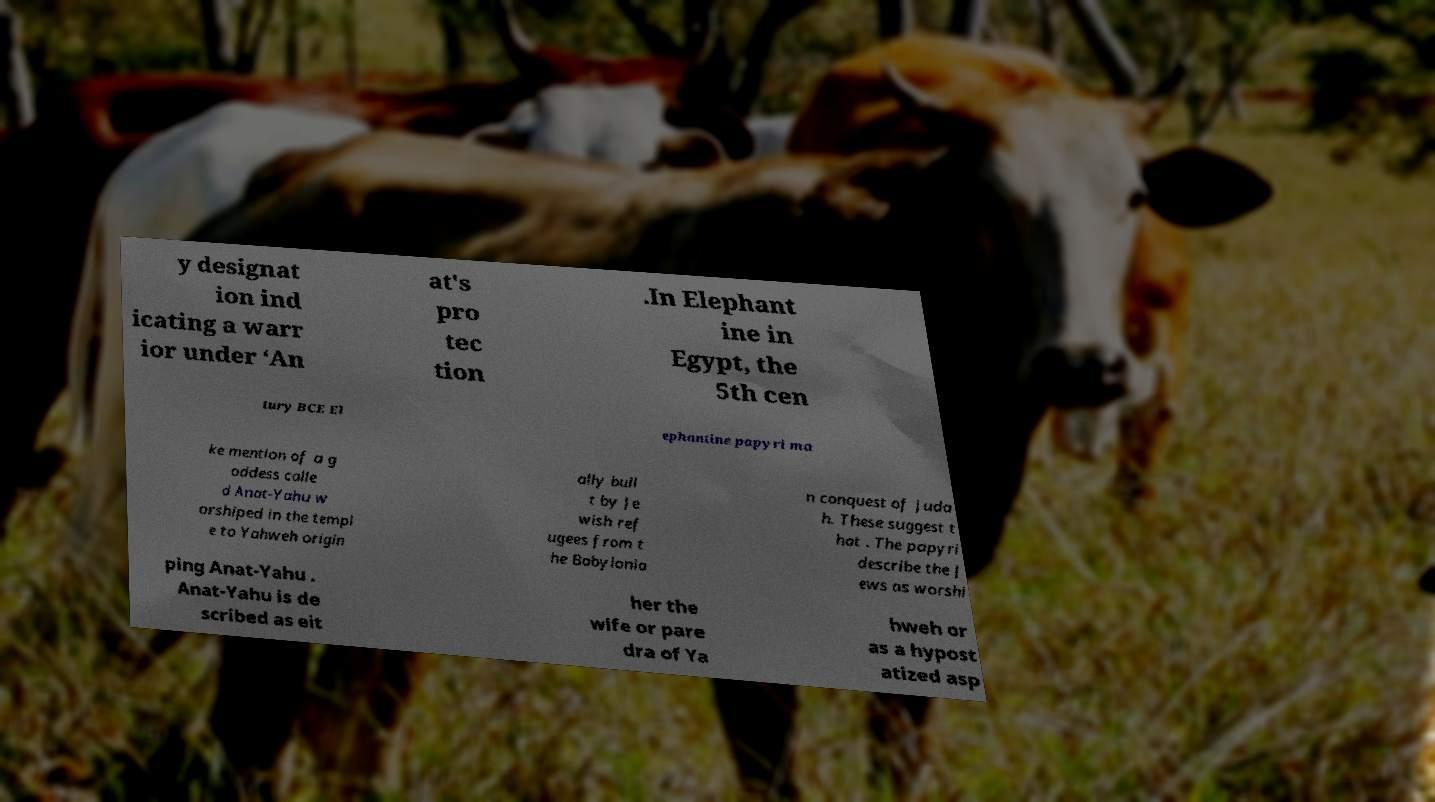Please identify and transcribe the text found in this image. y designat ion ind icating a warr ior under ‘An at's pro tec tion .In Elephant ine in Egypt, the 5th cen tury BCE El ephantine papyri ma ke mention of a g oddess calle d Anat-Yahu w orshiped in the templ e to Yahweh origin ally buil t by Je wish ref ugees from t he Babylonia n conquest of Juda h. These suggest t hat . The papyri describe the J ews as worshi ping Anat-Yahu . Anat-Yahu is de scribed as eit her the wife or pare dra of Ya hweh or as a hypost atized asp 